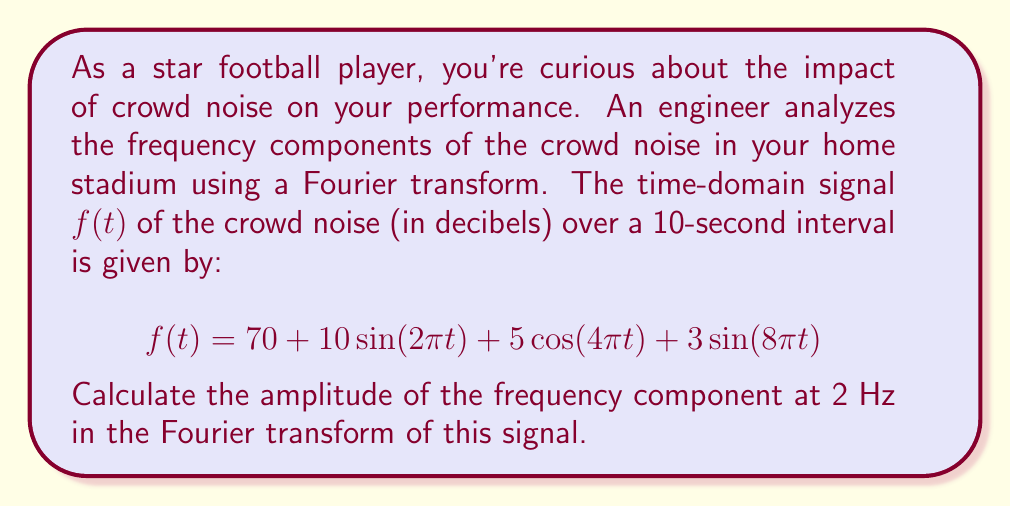Can you solve this math problem? To solve this problem, we need to follow these steps:

1) First, recall that the Fourier transform of a sinusoidal function is given by:

   $$\mathcal{F}\{A\sin(2\pi ft)\} = \frac{A}{2}i[\delta(F+f) - \delta(F-f)]$$
   $$\mathcal{F}\{A\cos(2\pi ft)\} = \frac{A}{2}[\delta(F+f) + \delta(F-f)]$$

   where $\delta$ is the Dirac delta function, $f$ is the frequency, and $F$ is the frequency variable in the Fourier domain.

2) In our signal, we have:
   
   - A constant term: 70
   - $10\sin(2\pi t)$, which has frequency 1 Hz
   - $5\cos(4\pi t)$, which has frequency 2 Hz
   - $3\sin(8\pi t)$, which has frequency 4 Hz

3) We're interested in the component at 2 Hz, which comes from the cosine term $5\cos(4\pi t)$.

4) Using the Fourier transform of cosine from step 1, we get:

   $$\mathcal{F}\{5\cos(4\pi t)\} = \frac{5}{2}[\delta(F+2) + \delta(F-2)]$$

5) The amplitude of this component in the frequency domain is therefore $\frac{5}{2} = 2.5$.

This means that in the frequency spectrum of the crowd noise, there is a spike of amplitude 2.5 at 2 Hz (and -2 Hz, but we typically only consider positive frequencies in practical applications).
Answer: The amplitude of the frequency component at 2 Hz in the Fourier transform of the crowd noise signal is 2.5. 